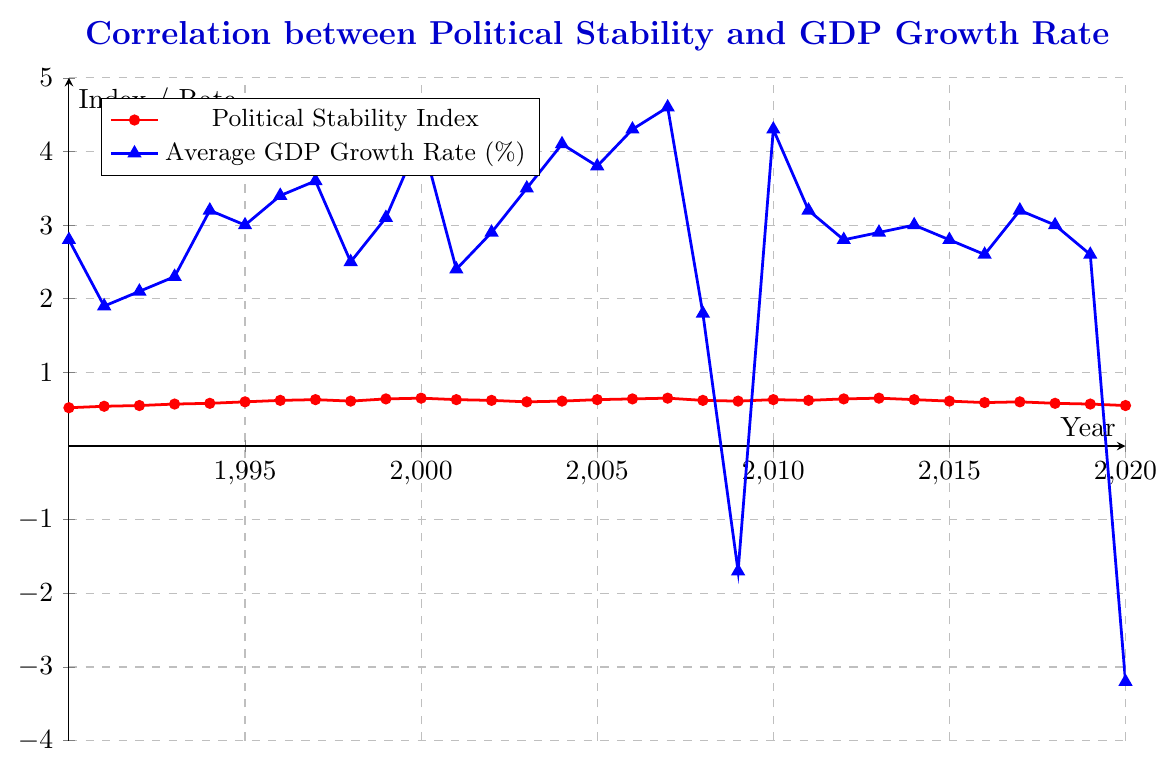What is the trend in Political Stability Index from 1990 to 2020? The figure shows a general increasing trend in the Political Stability Index from 1990 to 2007, followed by a decline from 2008 to 2020.
Answer: Increasing, then decreasing In which year did the Average GDP Growth Rate reach its peak, and what was the rate? The highest peak in the Average GDP Growth Rate is observed in 2007, where it reached 4.6%.
Answer: 2007, 4.6% Compare the Political Stability Index and Average GDP Growth Rate in the year 2000. Which one had a higher value? In 2000, the Political Stability Index was 0.65, and the Average GDP Growth Rate was 4.2%. The GDP Growth Rate was higher.
Answer: GDP Growth Rate Did the Average GDP Growth Rate ever go negative, and if so, in which years? The Average GDP Growth Rate went negative in 2009 with -1.7% and in 2020 with -3.2%.
Answer: 2009, 2020 Calculate the average Political Stability Index from 1990 to 2000. Sum the indices from 1990 to 2000 and divide by the number of years: (0.52+0.54+0.55+0.57+0.58+0.60+0.62+0.63+0.61+0.64+0.65)/11 = 0.598
Answer: 0.598 Between 2006 and 2014, how many years did both the Political Stability Index and Average GDP Growth Rate increase? By examining the intervals: 2006-2007 both increased, 2009-2010 both increased, 2012-2013 both increased. Thus, three years in total.
Answer: 3 Identify any significant drops in the Average GDP Growth Rate and corresponding years. The most significant drops are in 2008 (-2.5%) and 2020 (about -6%).
Answer: 2008, 2020 How does the overall trend of the GDP Growth Rate compare from 1990 to 2020? Initially, there is a growth trend until 2000. Post-2000, fluctuations occur with a significant dip in 2008 and 2020.
Answer: Fluctuating with significant dips Based on the figure, can you infer any correlation between Political Stability Index and Average GDP Growth Rate? Although there is some correlation during certain periods (higher stability with higher growth), overall it is not strongly consistent.
Answer: Weak correlation What is the difference in GDP Growth Rate between 2007 and 2008? The GDP Growth Rate in 2007 is 4.6% and in 2008 is 1.8%, so the difference is 4.6 - 1.8 = 2.8%.
Answer: 2.8% 